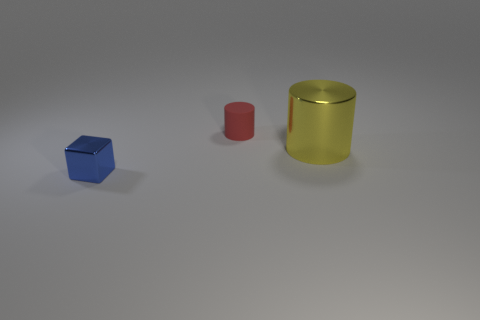Add 2 small red things. How many objects exist? 5 Subtract all red cylinders. How many cylinders are left? 1 Subtract 1 blocks. How many blocks are left? 0 Subtract all cyan blocks. How many yellow cylinders are left? 1 Add 3 yellow matte objects. How many yellow matte objects exist? 3 Subtract 0 blue spheres. How many objects are left? 3 Subtract all cubes. How many objects are left? 2 Subtract all gray cubes. Subtract all blue balls. How many cubes are left? 1 Subtract all tiny cyan balls. Subtract all small matte objects. How many objects are left? 2 Add 3 tiny cylinders. How many tiny cylinders are left? 4 